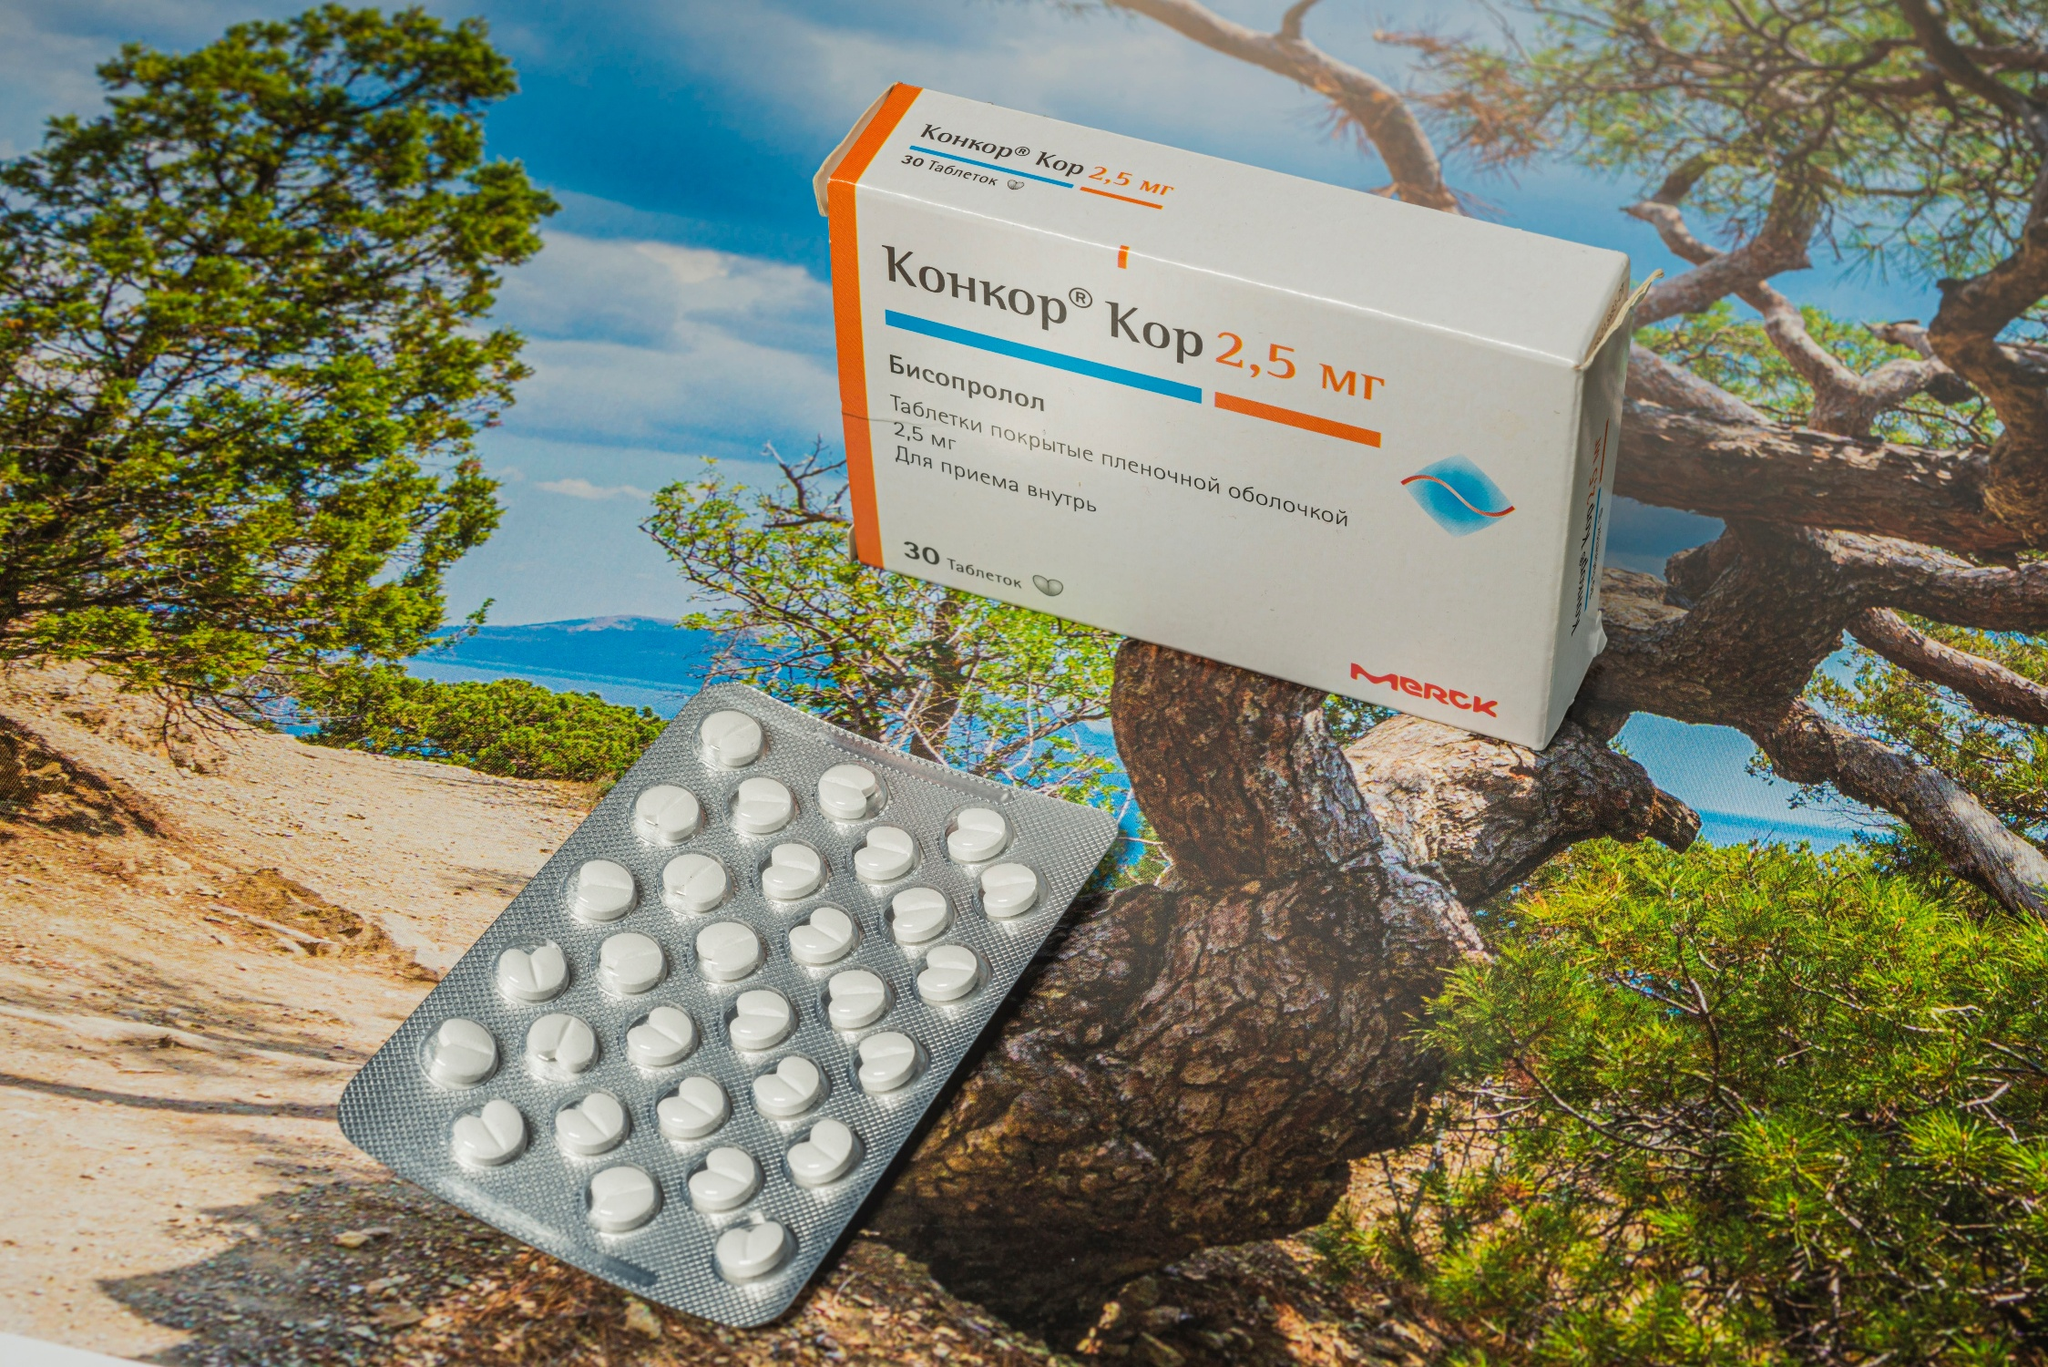Can you elaborate on the elements of the picture provided? The image showcases a box of 'Concor Кор 2,5 мг' (Kor 2.5 mg) pills along with a blister pack of the same medication, strategically placed on a rugged cliff overlooking a serene ocean. The pill box is designed with a subdued orange and white color scheme, prominently displaying the product name, while the silver blister pack reveals the white pills inside, hinting at their medical purpose. The background reveals a vivid natural scene with a sturdy tree, suggesting resilience, and the calm ocean hinting at tranquility and perhaps the healing nature of the medication. This placement might suggest a narrative or metaphor about the balance between human intervention (medicine) and nature's grandeur, inviting reflection on health, wellness, and environmental harmony. 